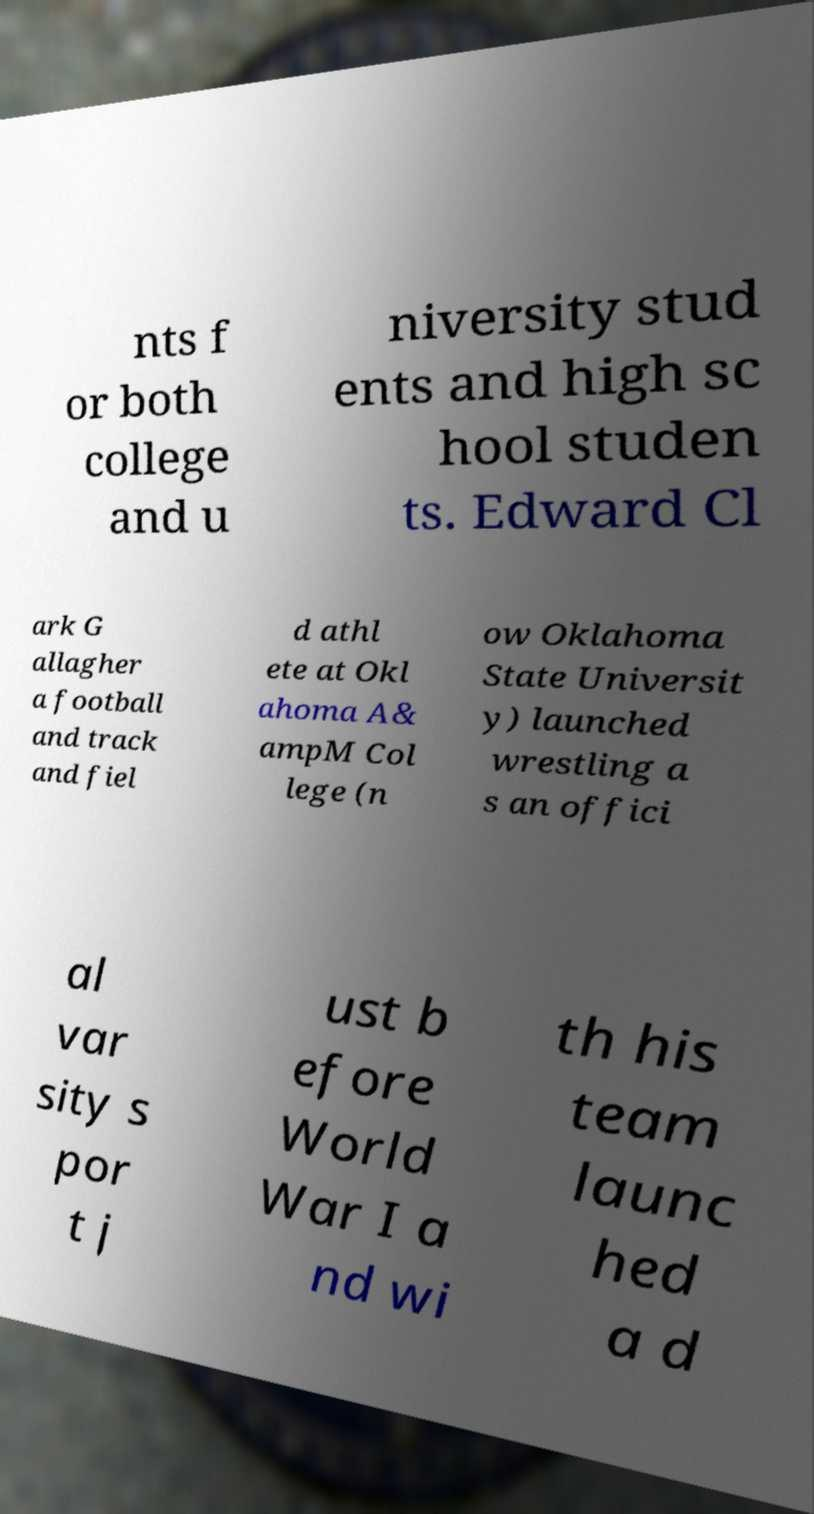Could you assist in decoding the text presented in this image and type it out clearly? nts f or both college and u niversity stud ents and high sc hool studen ts. Edward Cl ark G allagher a football and track and fiel d athl ete at Okl ahoma A& ampM Col lege (n ow Oklahoma State Universit y) launched wrestling a s an offici al var sity s por t j ust b efore World War I a nd wi th his team launc hed a d 